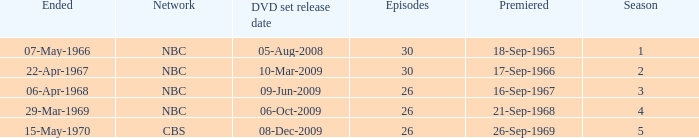When dis cbs release the DVD set? 08-Dec-2009. 